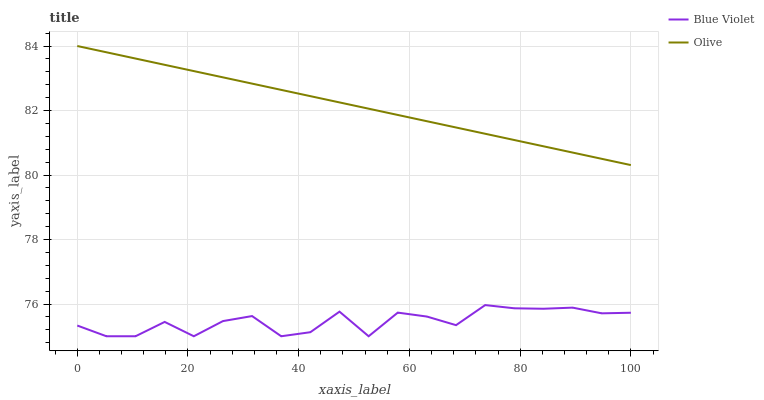Does Blue Violet have the minimum area under the curve?
Answer yes or no. Yes. Does Olive have the maximum area under the curve?
Answer yes or no. Yes. Does Blue Violet have the maximum area under the curve?
Answer yes or no. No. Is Olive the smoothest?
Answer yes or no. Yes. Is Blue Violet the roughest?
Answer yes or no. Yes. Is Blue Violet the smoothest?
Answer yes or no. No. Does Blue Violet have the lowest value?
Answer yes or no. Yes. Does Olive have the highest value?
Answer yes or no. Yes. Does Blue Violet have the highest value?
Answer yes or no. No. Is Blue Violet less than Olive?
Answer yes or no. Yes. Is Olive greater than Blue Violet?
Answer yes or no. Yes. Does Blue Violet intersect Olive?
Answer yes or no. No. 